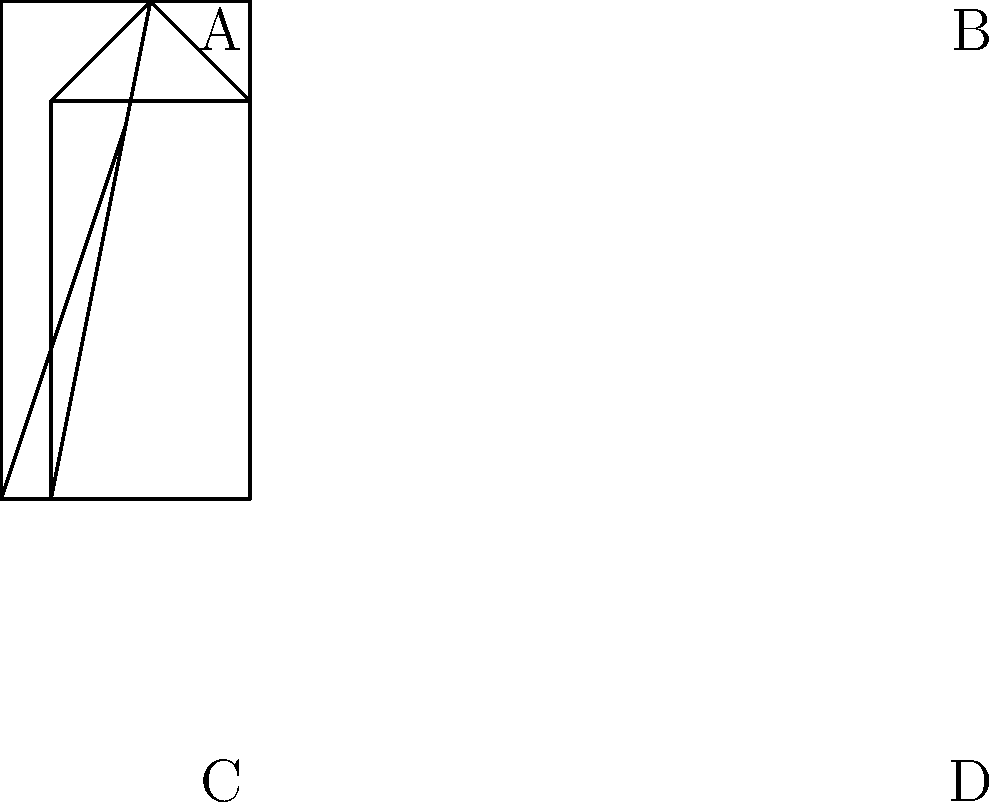As you're designing a unique guitar-shaped logo for your indie rock band, you come across this 3D representation of a stylized guitar. Which of the unfolded versions (A, B, C, or D) correctly represents this 3D shape when folded? To solve this problem, we need to analyze the 3D guitar shape and compare it with the given unfolded versions. Let's break it down step-by-step:

1. Observe the 3D guitar shape:
   - It has a rectangular body and a triangular headstock.
   - The body has four sides, and the headstock forms the fifth side.

2. Analyze the unfolded versions:
   A: This version has the correct overall shape but the triangular headstock is positioned incorrectly.
   B: This version has the triangular headstock as a separate piece, which is incorrect.
   C: This version has the correct shape and positioning of all elements.
   D: This version has an incorrect triangular shape in the middle of the body.

3. Compare the 3D shape with the unfolded versions:
   - The correct unfolded version should have a rectangular body with the triangular headstock attached to one of the shorter sides.
   - It should be possible to fold the shape back into the 3D guitar without any overlapping or missing parts.

4. Conclusion:
   Option C is the only version that correctly represents the 3D guitar shape when unfolded. It has the rectangular body and the triangular headstock in the correct position, allowing it to be folded back into the original 3D shape.

Therefore, the correct answer is C.
Answer: C 